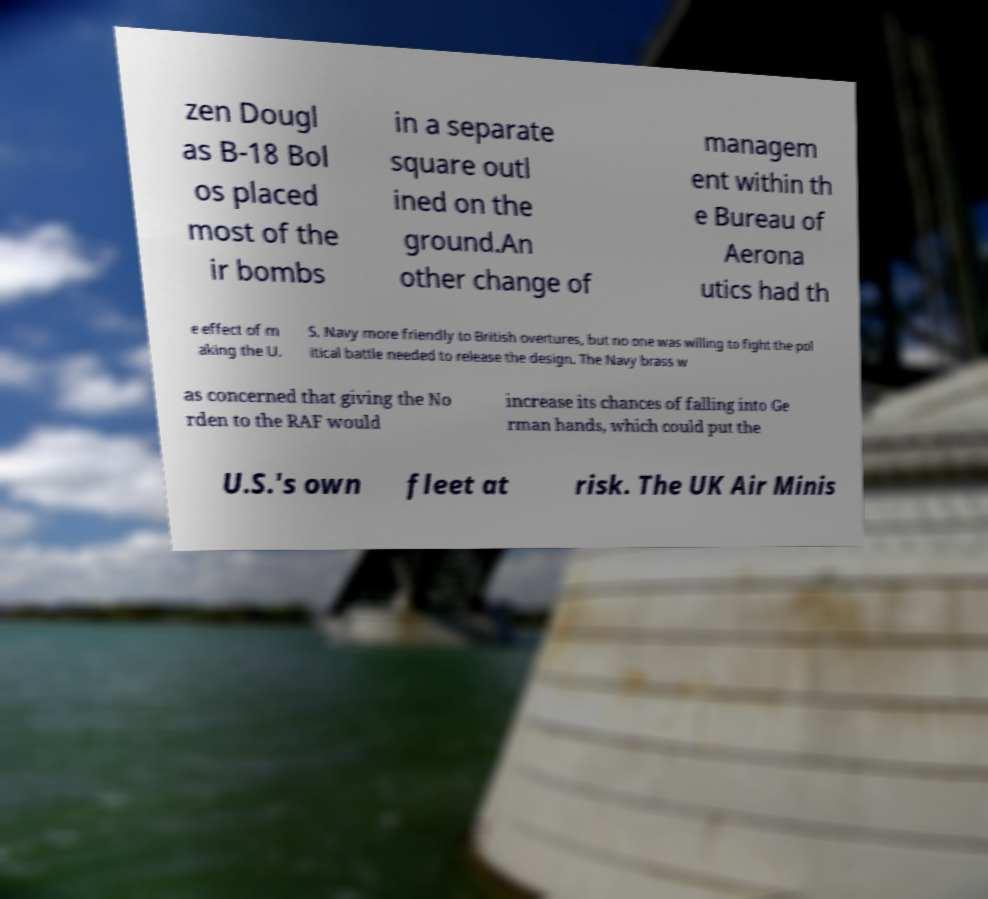Can you read and provide the text displayed in the image?This photo seems to have some interesting text. Can you extract and type it out for me? zen Dougl as B-18 Bol os placed most of the ir bombs in a separate square outl ined on the ground.An other change of managem ent within th e Bureau of Aerona utics had th e effect of m aking the U. S. Navy more friendly to British overtures, but no one was willing to fight the pol itical battle needed to release the design. The Navy brass w as concerned that giving the No rden to the RAF would increase its chances of falling into Ge rman hands, which could put the U.S.'s own fleet at risk. The UK Air Minis 